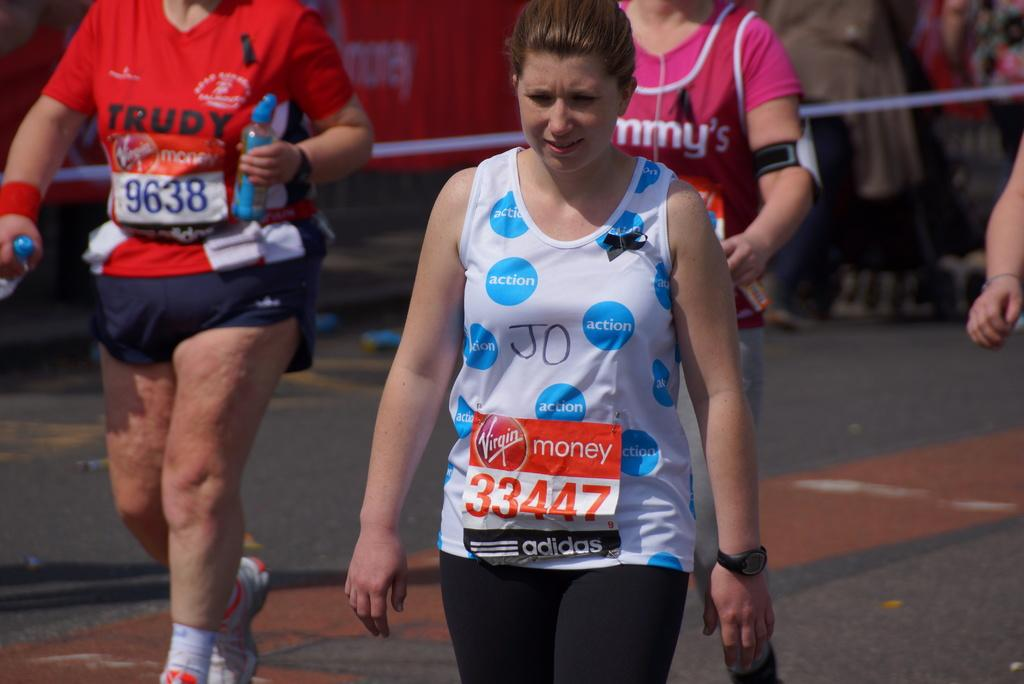<image>
Provide a brief description of the given image. A running sign that says Virgin money 33447 adidas 